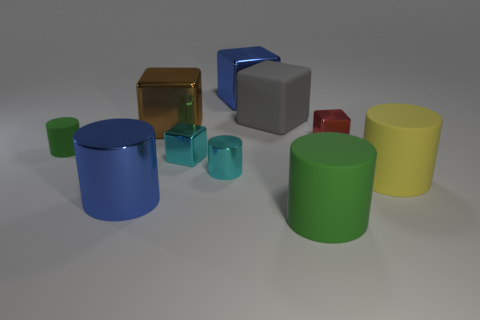Can you tell me what the largest object in the image is? The largest object in the image is the green cylinder on the right side. It's standing upright and towers over the other objects. 